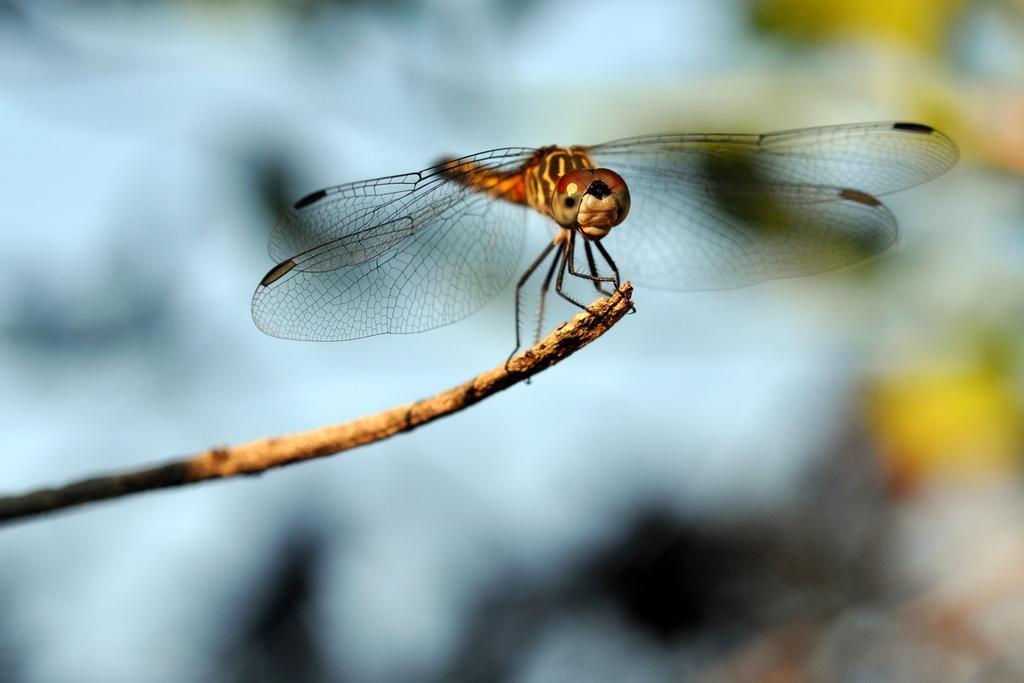Describe this image in one or two sentences. In this picture there is a dragonfly in the center of the image on a dry stem and the background is blurry. 